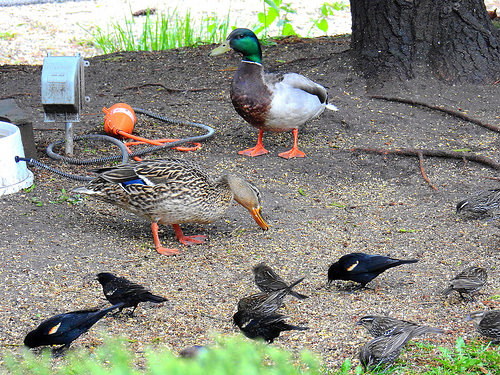<image>
Can you confirm if the bird is next to the duck? No. The bird is not positioned next to the duck. They are located in different areas of the scene. Is there a small bird in front of the duck? Yes. The small bird is positioned in front of the duck, appearing closer to the camera viewpoint. 